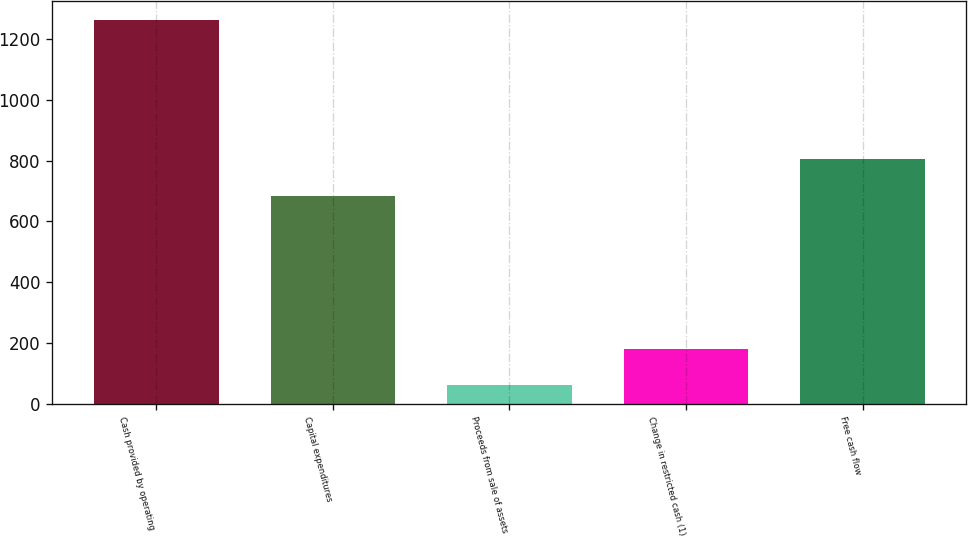Convert chart to OTSL. <chart><loc_0><loc_0><loc_500><loc_500><bar_chart><fcel>Cash provided by operating<fcel>Capital expenditures<fcel>Proceeds from sale of assets<fcel>Change in restricted cash (1)<fcel>Free cash flow<nl><fcel>1264<fcel>684<fcel>61<fcel>181.3<fcel>804.3<nl></chart> 